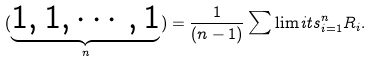<formula> <loc_0><loc_0><loc_500><loc_500>( \underbrace { 1 , 1 , \cdots , 1 } _ { n } ) = \frac { 1 } { ( n - 1 ) } \sum \lim i t s _ { i = 1 } ^ { n } R _ { i } .</formula> 